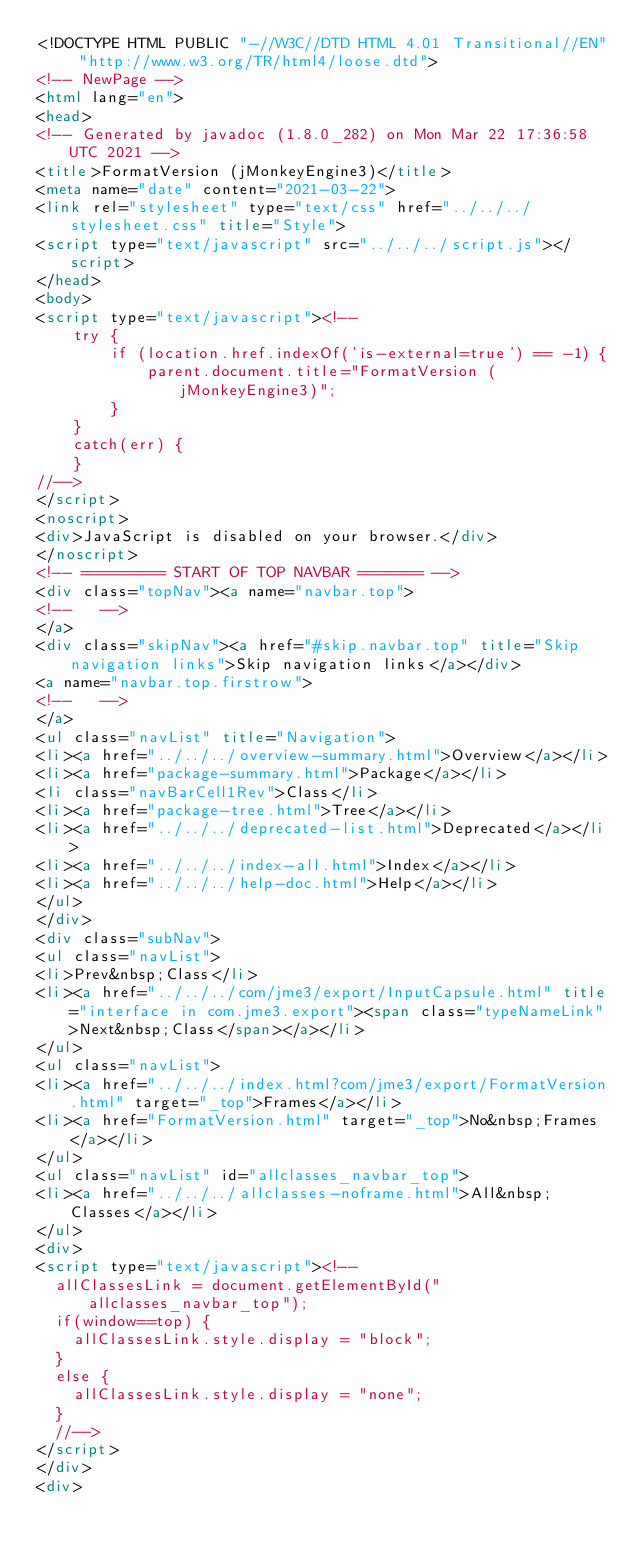<code> <loc_0><loc_0><loc_500><loc_500><_HTML_><!DOCTYPE HTML PUBLIC "-//W3C//DTD HTML 4.01 Transitional//EN" "http://www.w3.org/TR/html4/loose.dtd">
<!-- NewPage -->
<html lang="en">
<head>
<!-- Generated by javadoc (1.8.0_282) on Mon Mar 22 17:36:58 UTC 2021 -->
<title>FormatVersion (jMonkeyEngine3)</title>
<meta name="date" content="2021-03-22">
<link rel="stylesheet" type="text/css" href="../../../stylesheet.css" title="Style">
<script type="text/javascript" src="../../../script.js"></script>
</head>
<body>
<script type="text/javascript"><!--
    try {
        if (location.href.indexOf('is-external=true') == -1) {
            parent.document.title="FormatVersion (jMonkeyEngine3)";
        }
    }
    catch(err) {
    }
//-->
</script>
<noscript>
<div>JavaScript is disabled on your browser.</div>
</noscript>
<!-- ========= START OF TOP NAVBAR ======= -->
<div class="topNav"><a name="navbar.top">
<!--   -->
</a>
<div class="skipNav"><a href="#skip.navbar.top" title="Skip navigation links">Skip navigation links</a></div>
<a name="navbar.top.firstrow">
<!--   -->
</a>
<ul class="navList" title="Navigation">
<li><a href="../../../overview-summary.html">Overview</a></li>
<li><a href="package-summary.html">Package</a></li>
<li class="navBarCell1Rev">Class</li>
<li><a href="package-tree.html">Tree</a></li>
<li><a href="../../../deprecated-list.html">Deprecated</a></li>
<li><a href="../../../index-all.html">Index</a></li>
<li><a href="../../../help-doc.html">Help</a></li>
</ul>
</div>
<div class="subNav">
<ul class="navList">
<li>Prev&nbsp;Class</li>
<li><a href="../../../com/jme3/export/InputCapsule.html" title="interface in com.jme3.export"><span class="typeNameLink">Next&nbsp;Class</span></a></li>
</ul>
<ul class="navList">
<li><a href="../../../index.html?com/jme3/export/FormatVersion.html" target="_top">Frames</a></li>
<li><a href="FormatVersion.html" target="_top">No&nbsp;Frames</a></li>
</ul>
<ul class="navList" id="allclasses_navbar_top">
<li><a href="../../../allclasses-noframe.html">All&nbsp;Classes</a></li>
</ul>
<div>
<script type="text/javascript"><!--
  allClassesLink = document.getElementById("allclasses_navbar_top");
  if(window==top) {
    allClassesLink.style.display = "block";
  }
  else {
    allClassesLink.style.display = "none";
  }
  //-->
</script>
</div>
<div></code> 